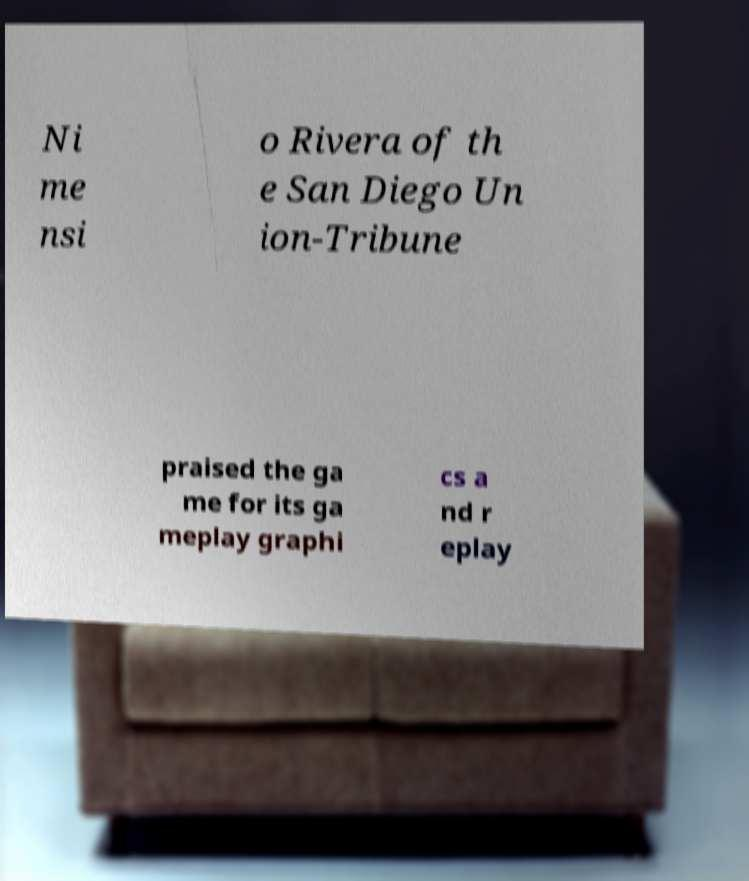Please read and relay the text visible in this image. What does it say? Ni me nsi o Rivera of th e San Diego Un ion-Tribune praised the ga me for its ga meplay graphi cs a nd r eplay 